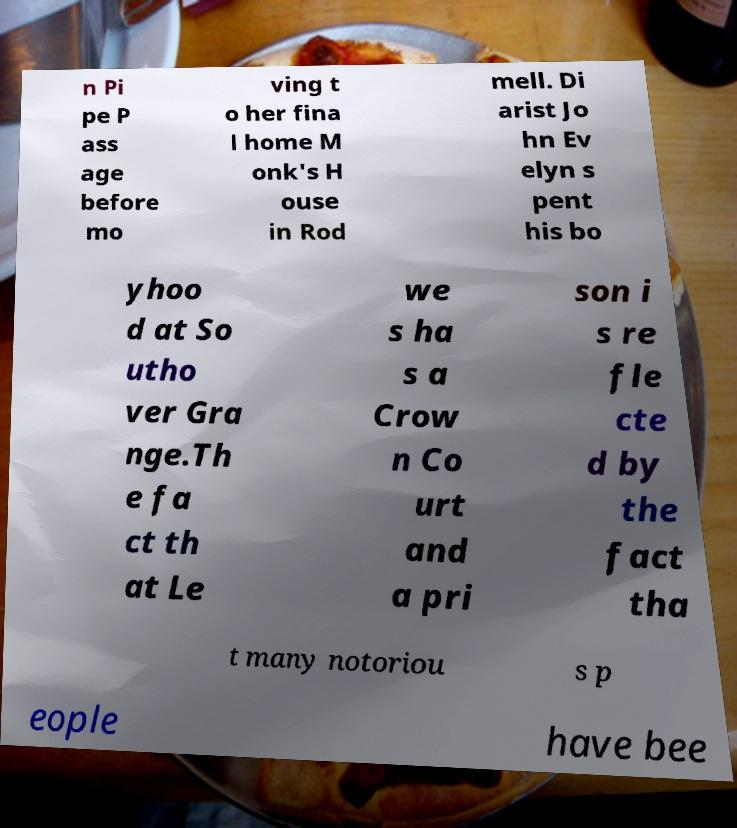Can you read and provide the text displayed in the image?This photo seems to have some interesting text. Can you extract and type it out for me? n Pi pe P ass age before mo ving t o her fina l home M onk's H ouse in Rod mell. Di arist Jo hn Ev elyn s pent his bo yhoo d at So utho ver Gra nge.Th e fa ct th at Le we s ha s a Crow n Co urt and a pri son i s re fle cte d by the fact tha t many notoriou s p eople have bee 